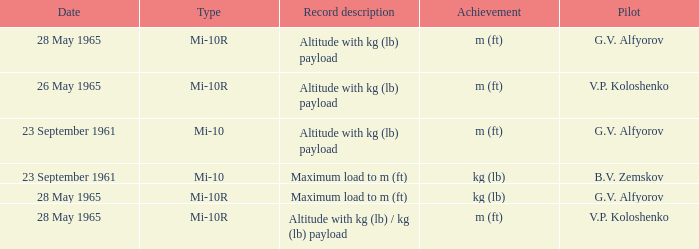Type of mi-10r, and a Record description of altitude with kg (lb) payload, and a Pilot of g.v. alfyorov is what date? 28 May 1965. 